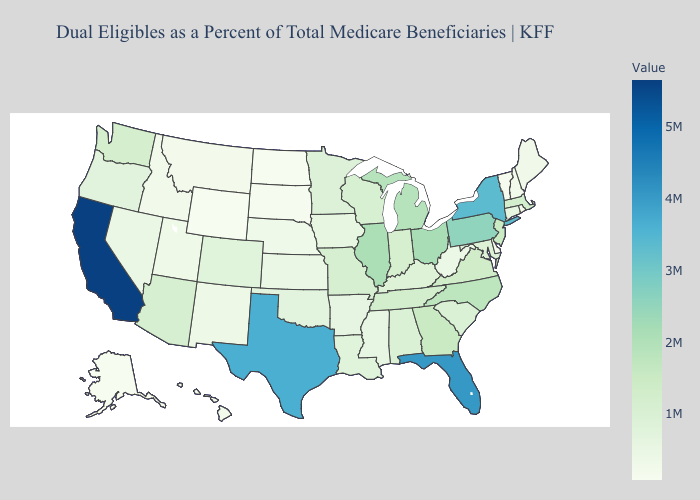Does Maryland have the lowest value in the South?
Quick response, please. No. Which states hav the highest value in the Northeast?
Concise answer only. New York. Among the states that border Virginia , does West Virginia have the lowest value?
Keep it brief. Yes. Among the states that border Florida , does Georgia have the lowest value?
Keep it brief. No. Does Oklahoma have a higher value than Wyoming?
Answer briefly. Yes. Does Massachusetts have a higher value than Rhode Island?
Short answer required. Yes. 